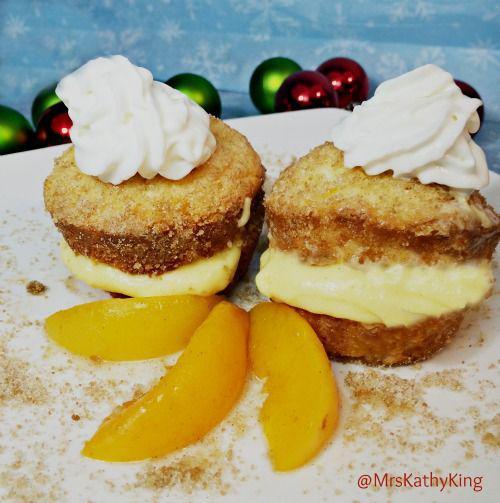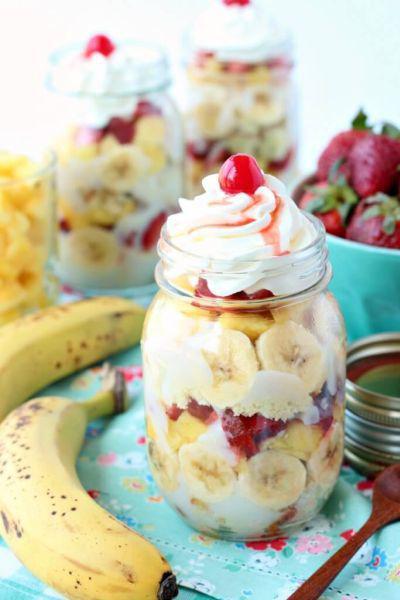The first image is the image on the left, the second image is the image on the right. Given the left and right images, does the statement "An image shows a whipped cream-topped dessert in a jar next to unpeeled bananas." hold true? Answer yes or no. Yes. The first image is the image on the left, the second image is the image on the right. Examine the images to the left and right. Is the description "A banana is shown near at least one of the desserts." accurate? Answer yes or no. Yes. 